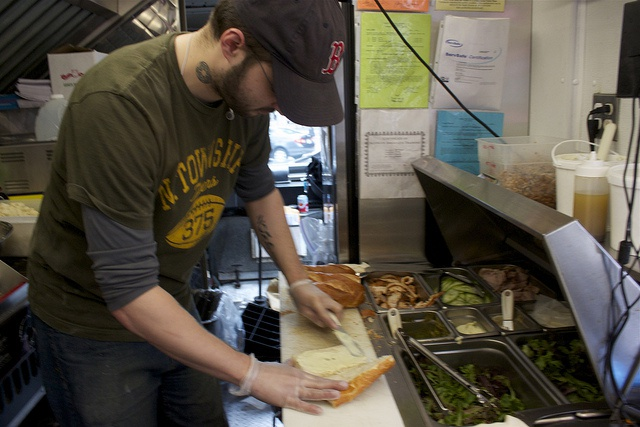Describe the objects in this image and their specific colors. I can see people in black, olive, and tan tones, sandwich in black, tan, and orange tones, car in black, white, lightblue, darkgray, and gray tones, knife in black and tan tones, and broccoli in black and darkgreen tones in this image. 